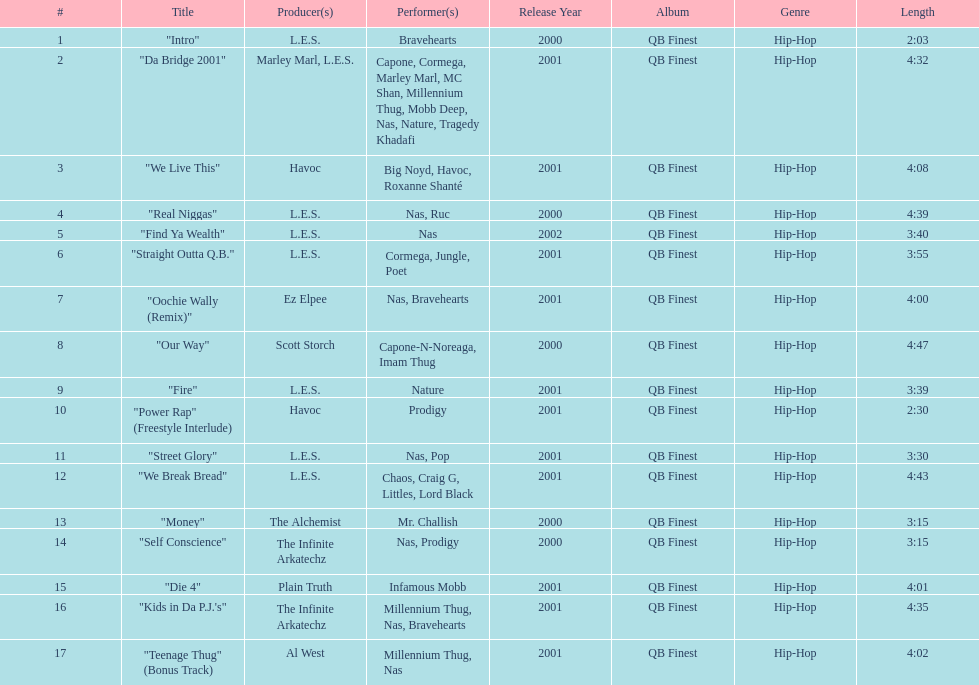What is the first song on the album produced by havoc? "We Live This". 